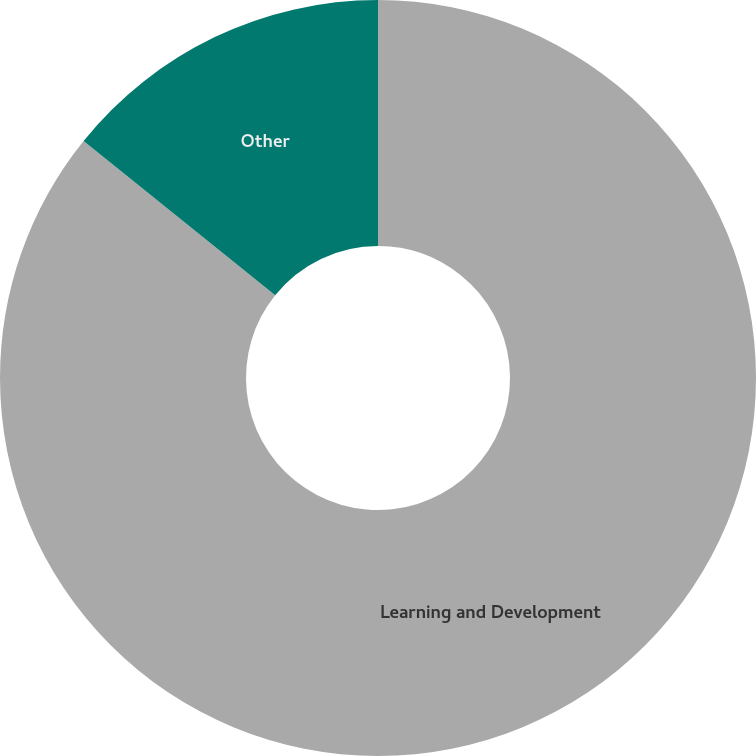Convert chart to OTSL. <chart><loc_0><loc_0><loc_500><loc_500><pie_chart><fcel>Learning and Development<fcel>Other<nl><fcel>85.79%<fcel>14.21%<nl></chart> 